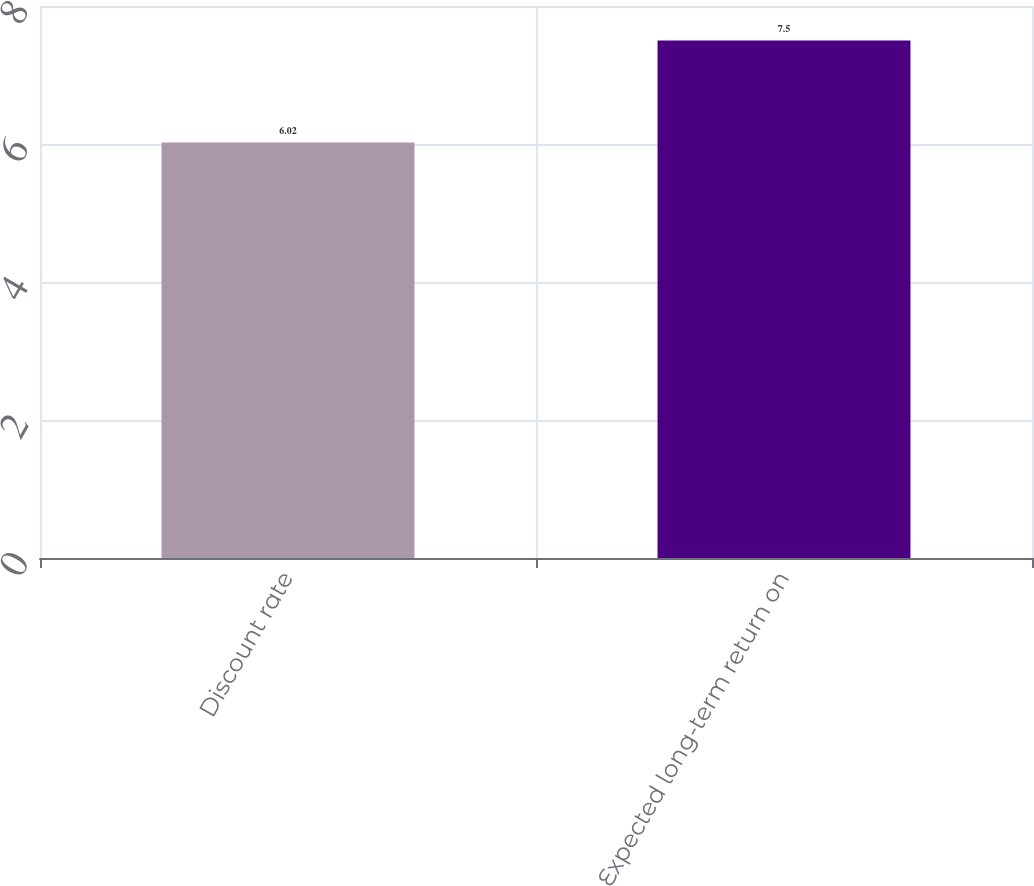Convert chart. <chart><loc_0><loc_0><loc_500><loc_500><bar_chart><fcel>Discount rate<fcel>Expected long-term return on<nl><fcel>6.02<fcel>7.5<nl></chart> 